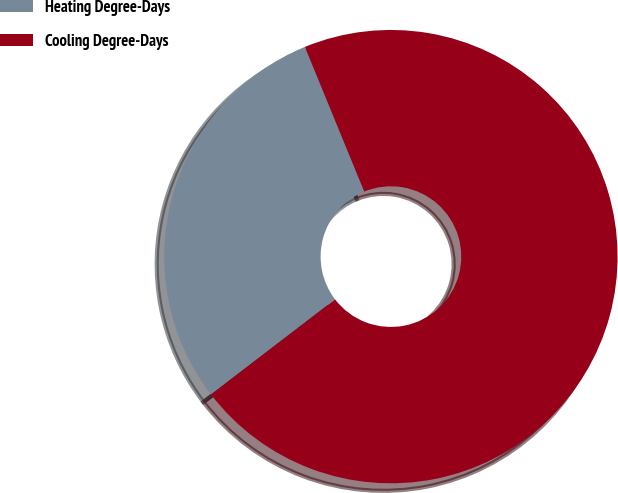<chart> <loc_0><loc_0><loc_500><loc_500><pie_chart><fcel>Heating Degree-Days<fcel>Cooling Degree-Days<nl><fcel>29.21%<fcel>70.79%<nl></chart> 